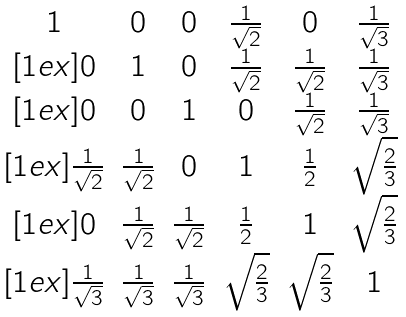<formula> <loc_0><loc_0><loc_500><loc_500>\begin{matrix} 1 & 0 & 0 & \frac { 1 } { \sqrt { 2 } } & 0 & \frac { 1 } { \sqrt { 3 } } \\ [ 1 e x ] 0 & 1 & 0 & \frac { 1 } { \sqrt { 2 } } & \frac { 1 } { \sqrt { 2 } } & \frac { 1 } { \sqrt { 3 } } \\ [ 1 e x ] 0 & 0 & 1 & 0 & \frac { 1 } { \sqrt { 2 } } & \frac { 1 } { \sqrt { 3 } } \\ [ 1 e x ] \frac { 1 } { \sqrt { 2 } } & \frac { 1 } { \sqrt { 2 } } & 0 & 1 & \frac { 1 } { 2 } & \sqrt { \frac { 2 } { 3 } } \\ [ 1 e x ] 0 & \frac { 1 } { \sqrt { 2 } } & \frac { 1 } { \sqrt { 2 } } & \frac { 1 } { 2 } & 1 & \sqrt { \frac { 2 } { 3 } } \\ [ 1 e x ] \frac { 1 } { \sqrt { 3 } } & \frac { 1 } { \sqrt { 3 } } & \frac { 1 } { \sqrt { 3 } } & \sqrt { \frac { 2 } { 3 } } & \sqrt { \frac { 2 } { 3 } } & 1 \end{matrix}</formula> 